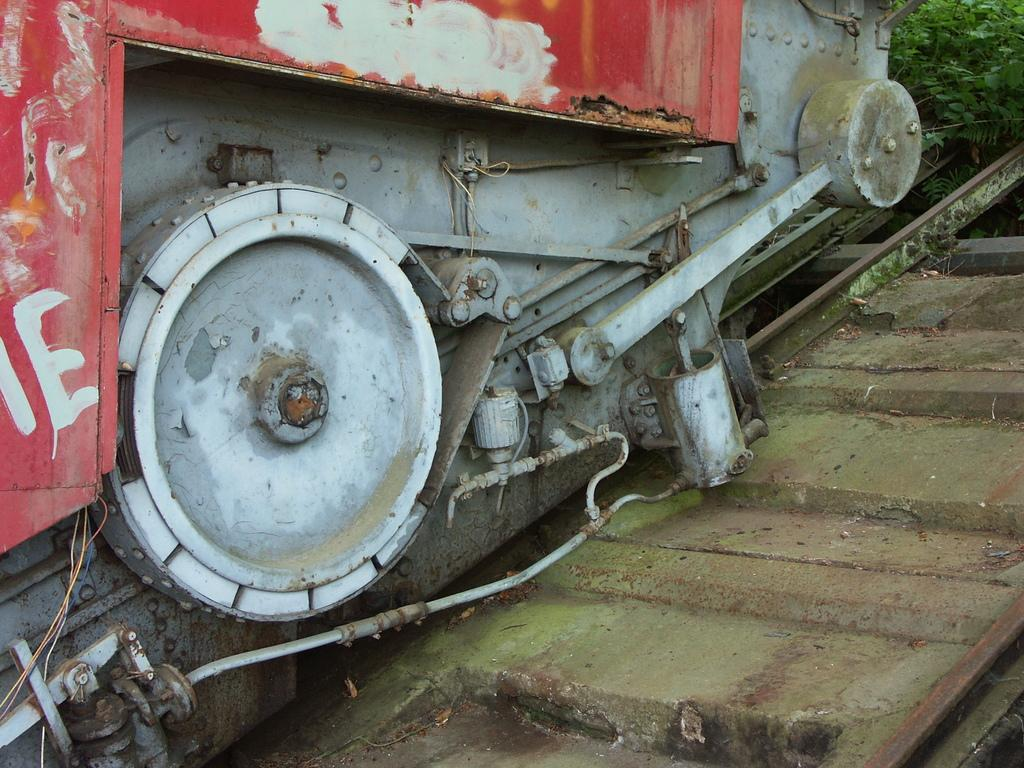What is the main subject of the image? There is a part of a train in the image. Where is the train located? The train is on a railway track. What can be seen in the top right corner of the image? There are plants visible in the top right corner of the image. What type of shirt is the monkey wearing in the image? There is no monkey present in the image, and therefore no shirt can be observed. 